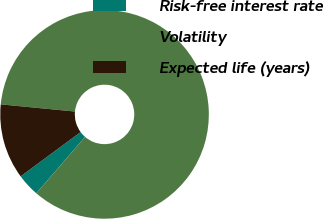Convert chart to OTSL. <chart><loc_0><loc_0><loc_500><loc_500><pie_chart><fcel>Risk-free interest rate<fcel>Volatility<fcel>Expected life (years)<nl><fcel>3.53%<fcel>84.82%<fcel>11.66%<nl></chart> 